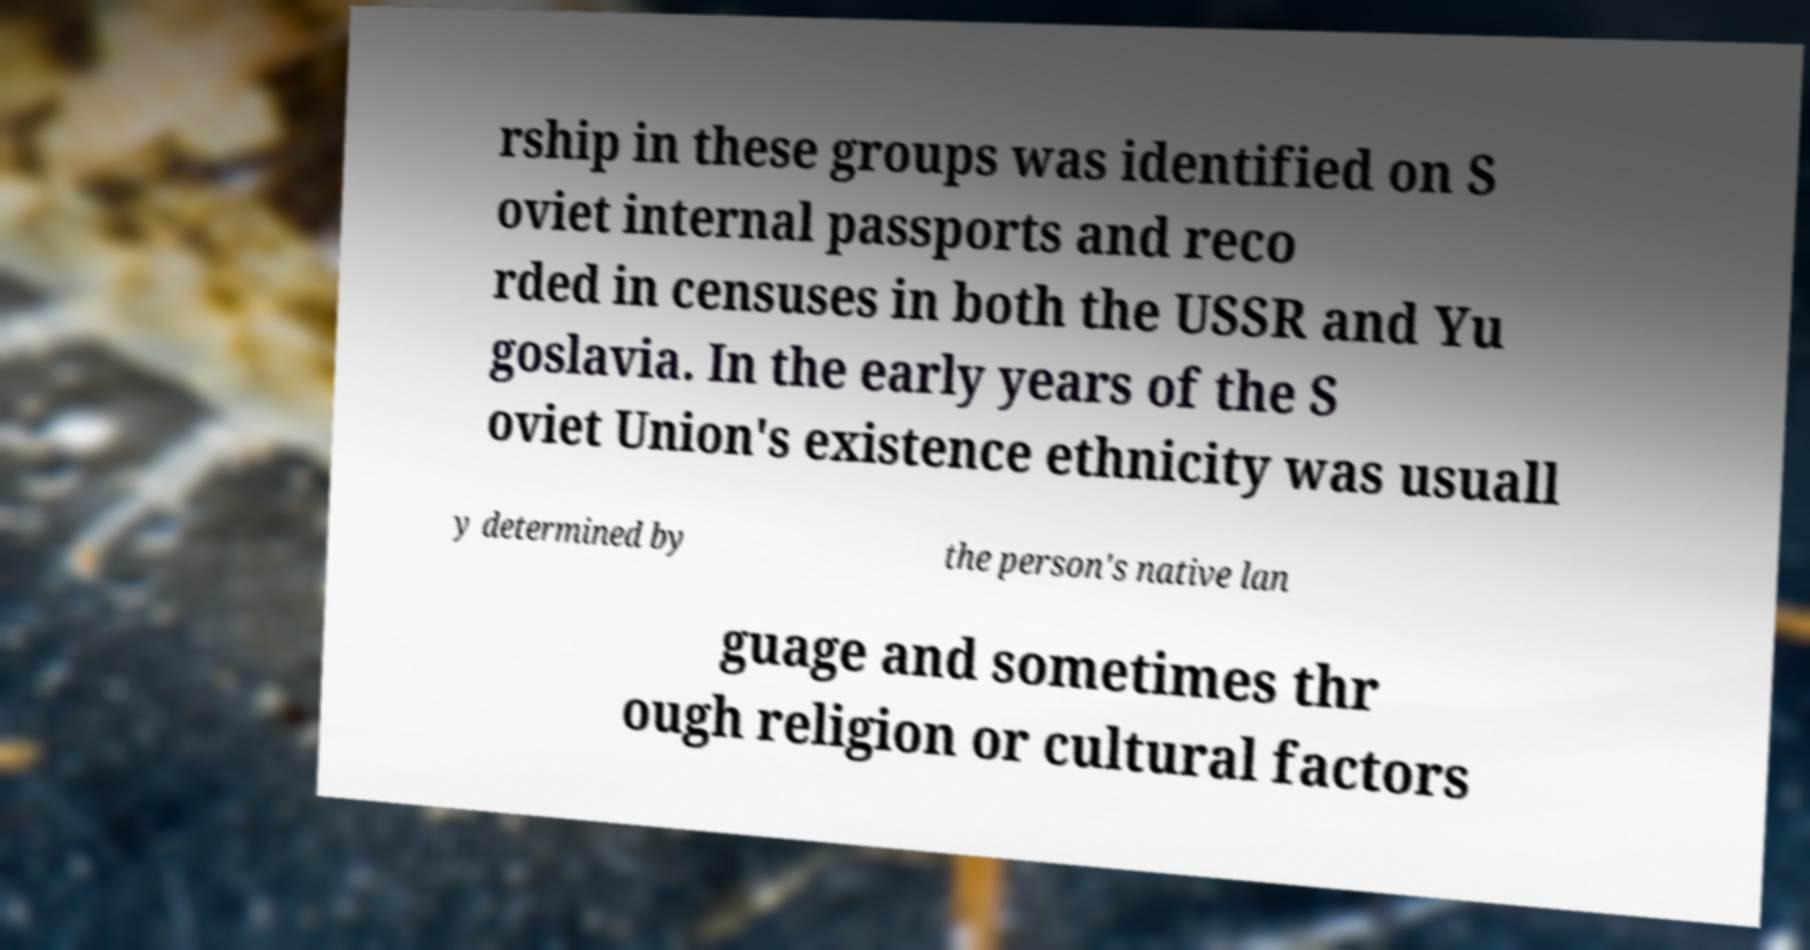Please identify and transcribe the text found in this image. rship in these groups was identified on S oviet internal passports and reco rded in censuses in both the USSR and Yu goslavia. In the early years of the S oviet Union's existence ethnicity was usuall y determined by the person's native lan guage and sometimes thr ough religion or cultural factors 